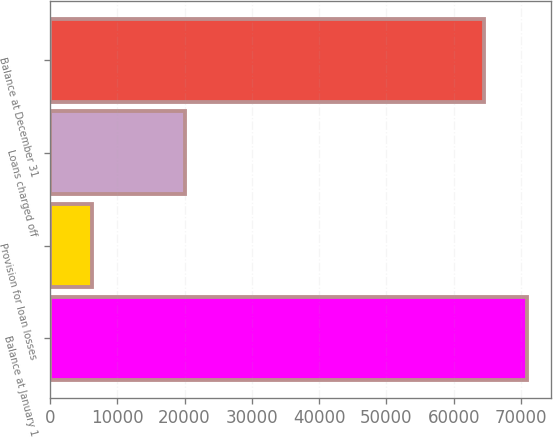Convert chart to OTSL. <chart><loc_0><loc_0><loc_500><loc_500><bar_chart><fcel>Balance at January 1<fcel>Provision for loan losses<fcel>Loans charged off<fcel>Balance at December 31<nl><fcel>70927.7<fcel>6223<fcel>20140<fcel>64500<nl></chart> 